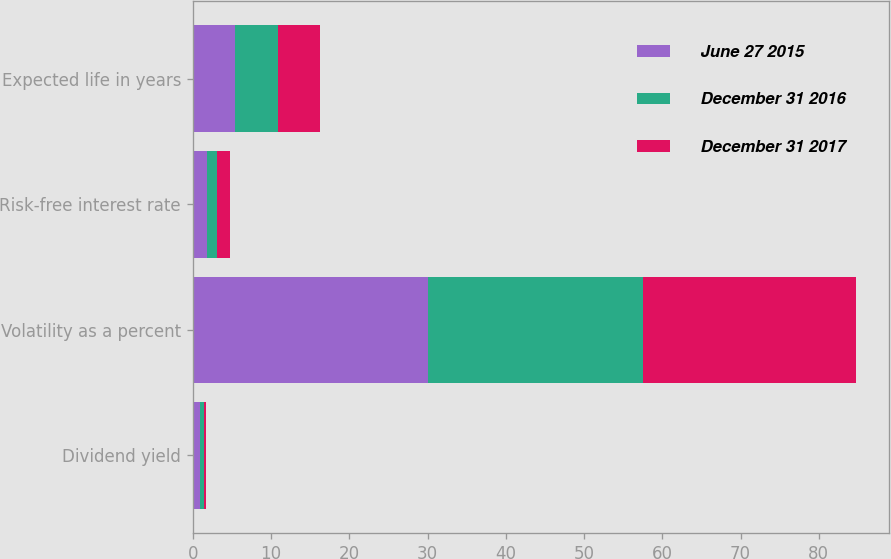Convert chart to OTSL. <chart><loc_0><loc_0><loc_500><loc_500><stacked_bar_chart><ecel><fcel>Dividend yield<fcel>Volatility as a percent<fcel>Risk-free interest rate<fcel>Expected life in years<nl><fcel>June 27 2015<fcel>0.9<fcel>30<fcel>1.8<fcel>5.41<nl><fcel>December 31 2016<fcel>0.5<fcel>27.6<fcel>1.3<fcel>5.5<nl><fcel>December 31 2017<fcel>0.3<fcel>27.1<fcel>1.7<fcel>5.3<nl></chart> 